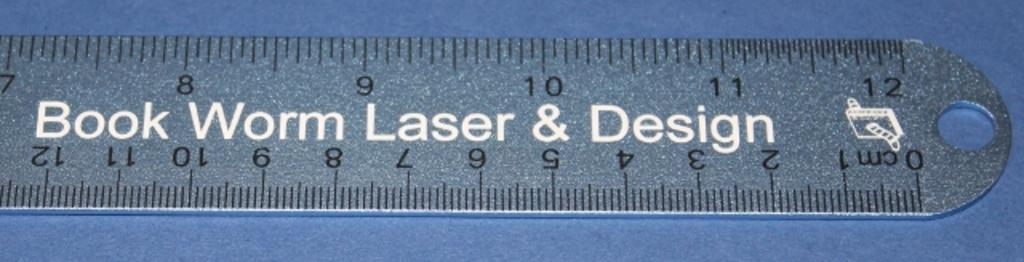<image>
Share a concise interpretation of the image provided. ruler in inches and cm from book work laser & design 